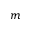<formula> <loc_0><loc_0><loc_500><loc_500>m</formula> 